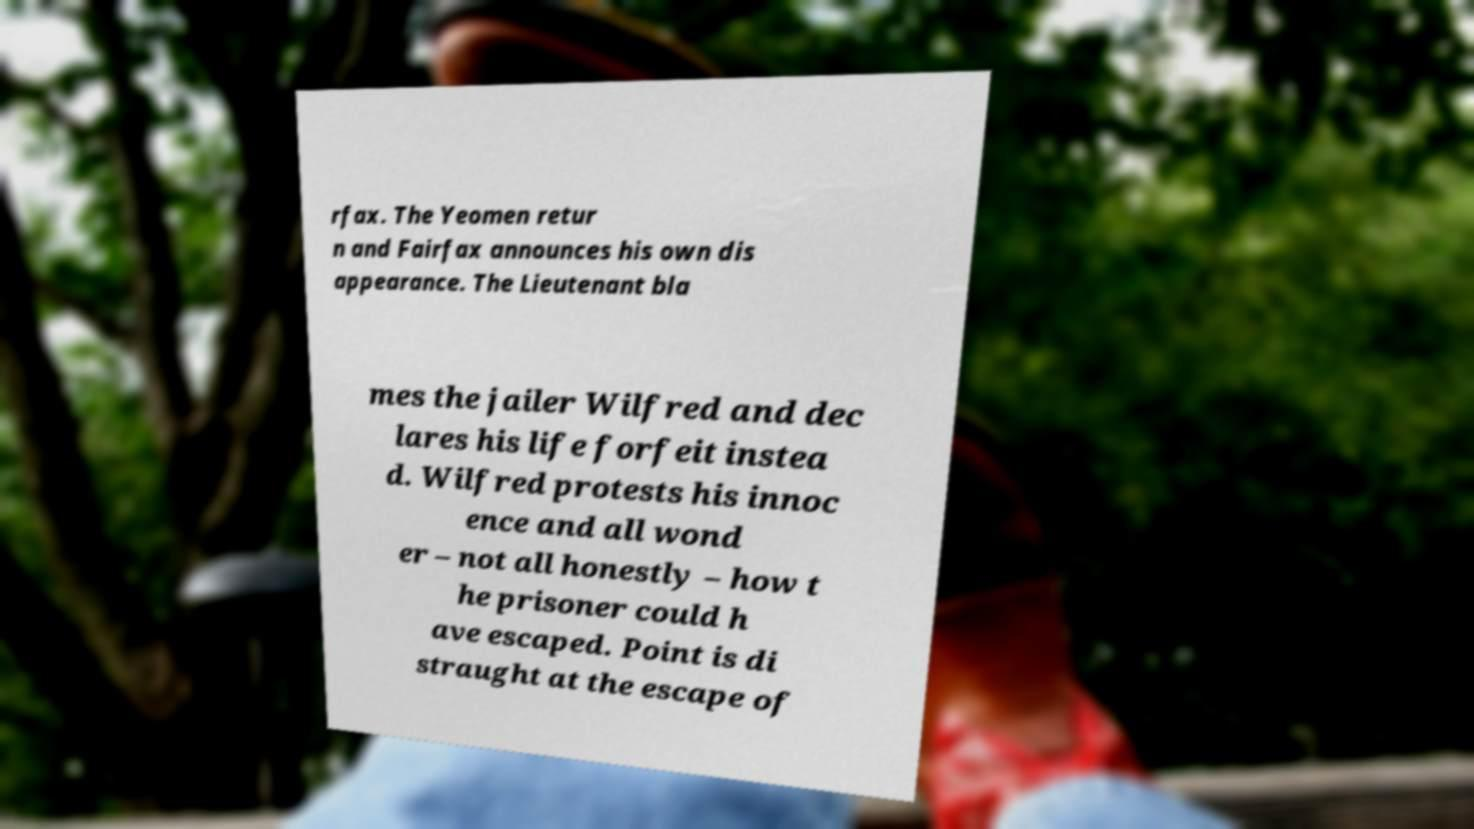Could you extract and type out the text from this image? rfax. The Yeomen retur n and Fairfax announces his own dis appearance. The Lieutenant bla mes the jailer Wilfred and dec lares his life forfeit instea d. Wilfred protests his innoc ence and all wond er – not all honestly – how t he prisoner could h ave escaped. Point is di straught at the escape of 